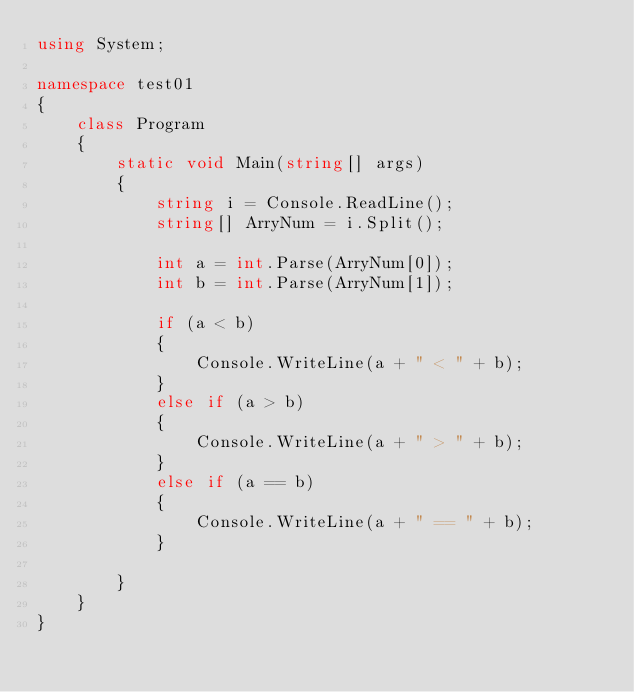Convert code to text. <code><loc_0><loc_0><loc_500><loc_500><_C#_>using System;

namespace test01
{
    class Program
    {
        static void Main(string[] args)
        {
            string i = Console.ReadLine();
            string[] ArryNum = i.Split();

            int a = int.Parse(ArryNum[0]);
            int b = int.Parse(ArryNum[1]);

            if (a < b)
            {
                Console.WriteLine(a + " < " + b);
            }
            else if (a > b)
            {
                Console.WriteLine(a + " > " + b);
            }
            else if (a == b)
            {
                Console.WriteLine(a + " == " + b);
            }

        }
    }
}</code> 